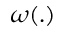Convert formula to latex. <formula><loc_0><loc_0><loc_500><loc_500>\boldsymbol \omega ( . )</formula> 